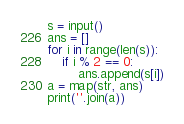<code> <loc_0><loc_0><loc_500><loc_500><_Python_>s = input()
ans = []
for i in range(len(s)):
    if i % 2 == 0:
        ans.append(s[i])
a = map(str, ans)
print(''.join(a))</code> 